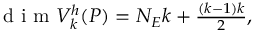<formula> <loc_0><loc_0><loc_500><loc_500>\begin{array} { r } { d i m V _ { k } ^ { h } ( { P } ) = N _ { E } k + \frac { ( k - 1 ) k } { 2 } , } \end{array}</formula> 